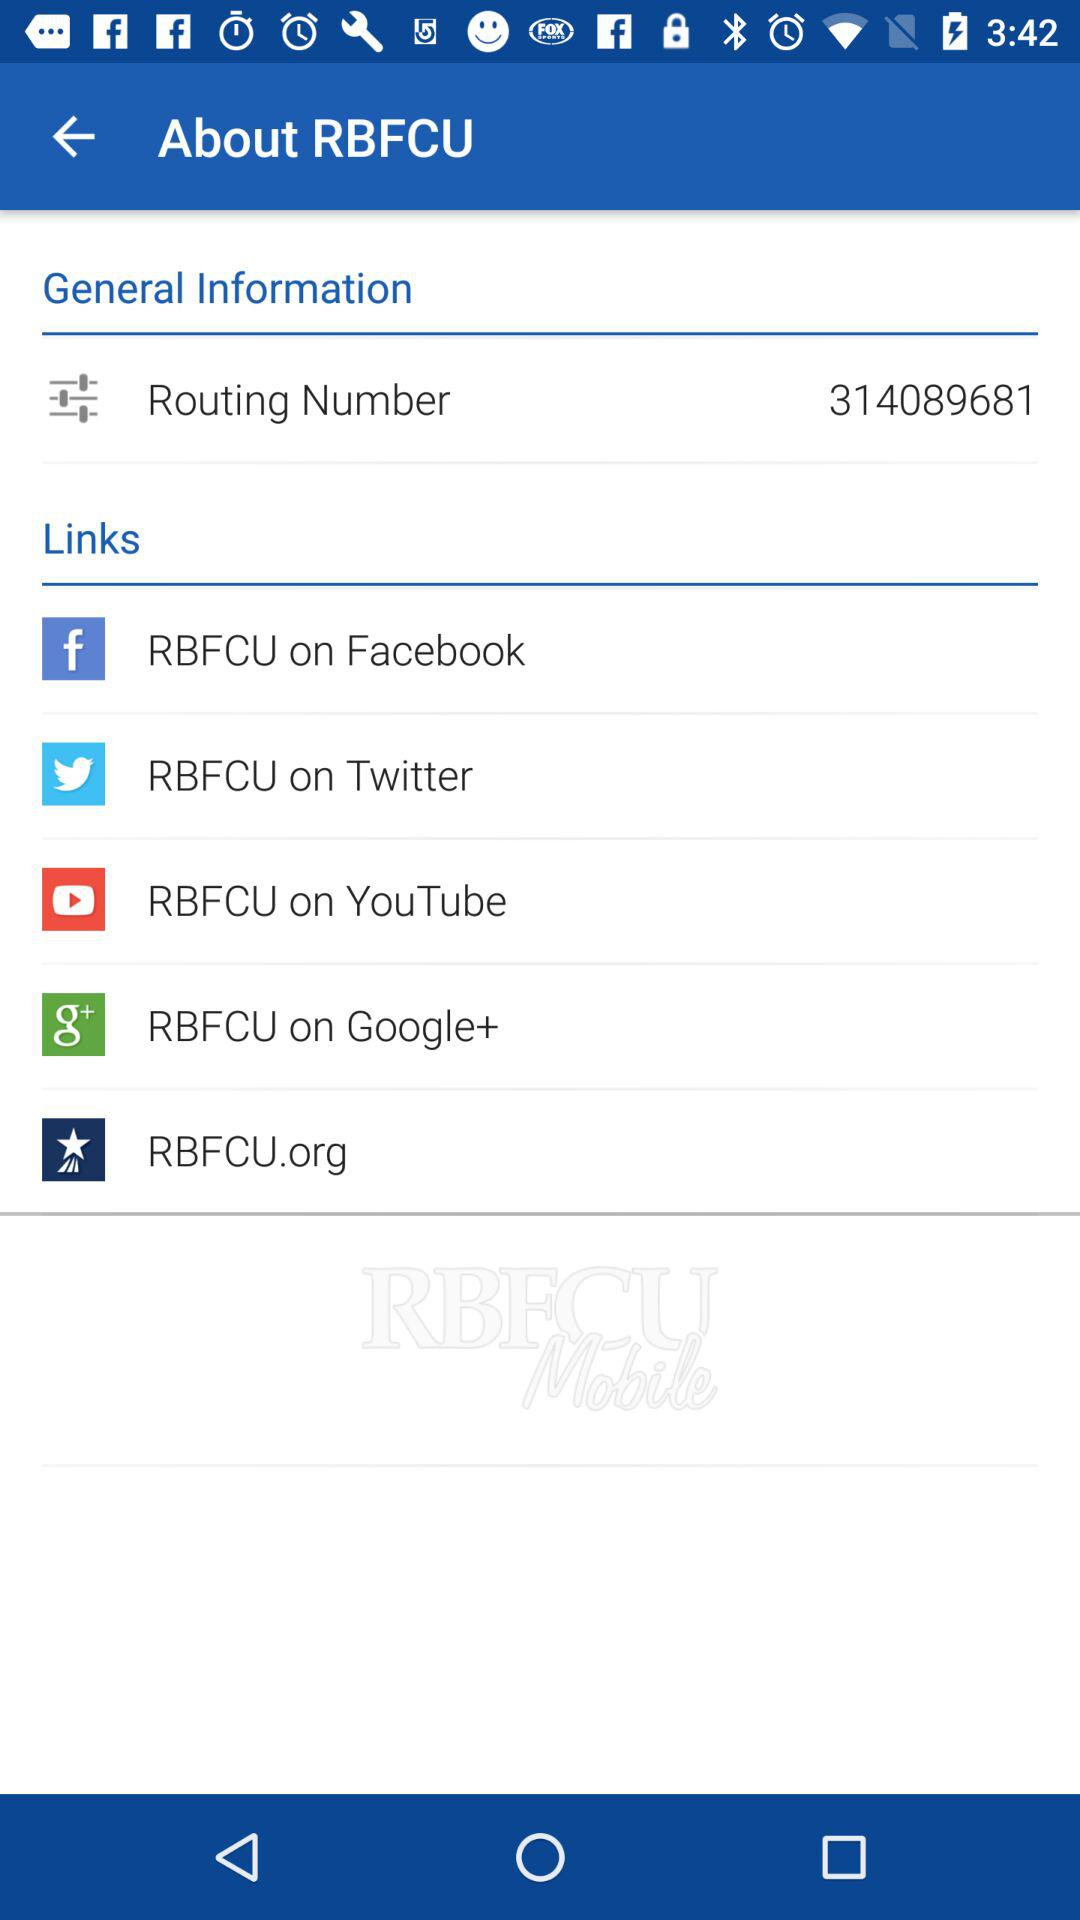What is the routing number? The routing number is 314089681. 